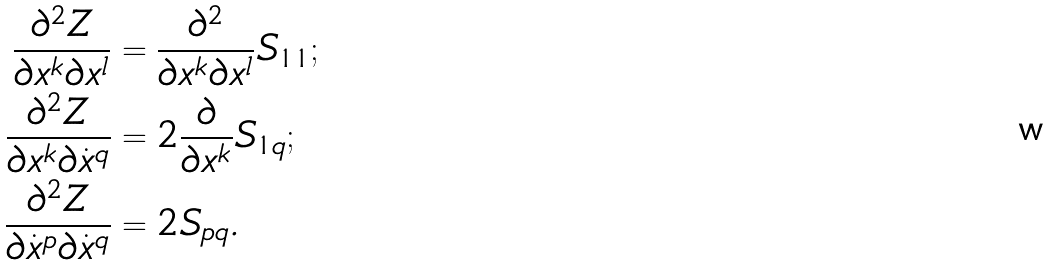<formula> <loc_0><loc_0><loc_500><loc_500>\frac { \partial ^ { 2 } Z } { \partial x ^ { k } \partial x ^ { l } } & = \frac { \partial ^ { 2 } } { \partial x ^ { k } \partial x ^ { l } } S _ { 1 1 } ; \\ \frac { \partial ^ { 2 } Z } { \partial x ^ { k } \partial \dot { x } ^ { q } } & = 2 \frac { \partial } { \partial x ^ { k } } S _ { 1 q } ; \\ \frac { \partial ^ { 2 } Z } { \partial \dot { x } ^ { p } \partial \dot { x } ^ { q } } & = 2 S _ { p q } .</formula> 